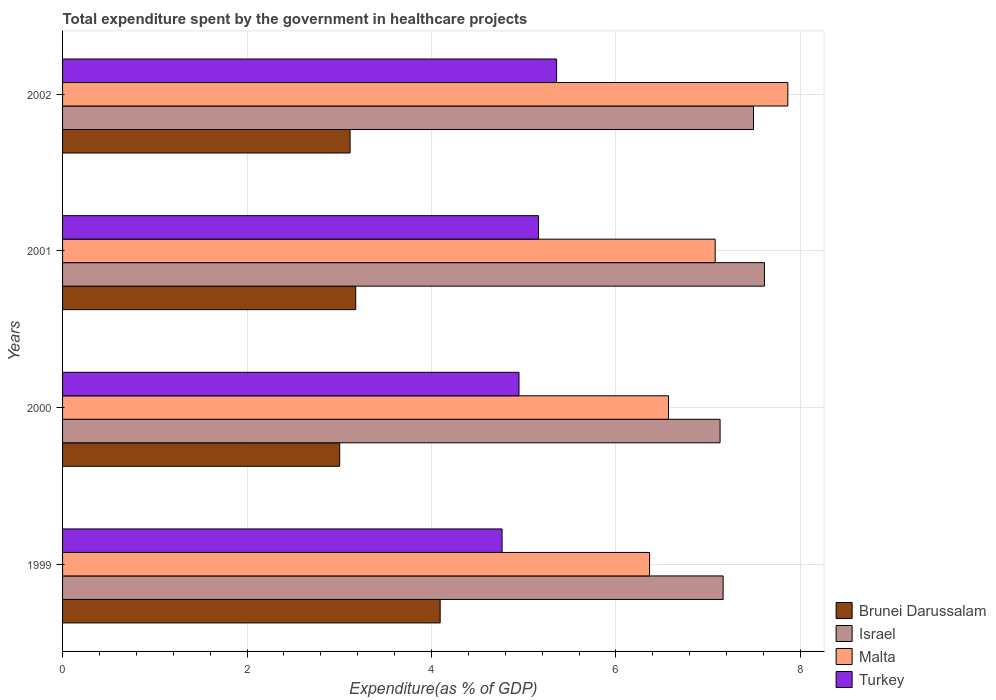How many bars are there on the 2nd tick from the top?
Your answer should be compact. 4. What is the label of the 2nd group of bars from the top?
Ensure brevity in your answer.  2001. In how many cases, is the number of bars for a given year not equal to the number of legend labels?
Provide a succinct answer. 0. What is the total expenditure spent by the government in healthcare projects in Malta in 2000?
Provide a short and direct response. 6.57. Across all years, what is the maximum total expenditure spent by the government in healthcare projects in Malta?
Your answer should be very brief. 7.86. Across all years, what is the minimum total expenditure spent by the government in healthcare projects in Israel?
Your answer should be very brief. 7.13. In which year was the total expenditure spent by the government in healthcare projects in Malta minimum?
Keep it short and to the point. 1999. What is the total total expenditure spent by the government in healthcare projects in Israel in the graph?
Your response must be concise. 29.39. What is the difference between the total expenditure spent by the government in healthcare projects in Brunei Darussalam in 2000 and that in 2001?
Your answer should be compact. -0.17. What is the difference between the total expenditure spent by the government in healthcare projects in Turkey in 1999 and the total expenditure spent by the government in healthcare projects in Israel in 2002?
Keep it short and to the point. -2.73. What is the average total expenditure spent by the government in healthcare projects in Israel per year?
Provide a succinct answer. 7.35. In the year 1999, what is the difference between the total expenditure spent by the government in healthcare projects in Turkey and total expenditure spent by the government in healthcare projects in Brunei Darussalam?
Give a very brief answer. 0.67. What is the ratio of the total expenditure spent by the government in healthcare projects in Brunei Darussalam in 2000 to that in 2002?
Ensure brevity in your answer.  0.96. Is the difference between the total expenditure spent by the government in healthcare projects in Turkey in 2001 and 2002 greater than the difference between the total expenditure spent by the government in healthcare projects in Brunei Darussalam in 2001 and 2002?
Give a very brief answer. No. What is the difference between the highest and the second highest total expenditure spent by the government in healthcare projects in Brunei Darussalam?
Make the answer very short. 0.92. What is the difference between the highest and the lowest total expenditure spent by the government in healthcare projects in Israel?
Your answer should be compact. 0.48. Is it the case that in every year, the sum of the total expenditure spent by the government in healthcare projects in Malta and total expenditure spent by the government in healthcare projects in Turkey is greater than the sum of total expenditure spent by the government in healthcare projects in Israel and total expenditure spent by the government in healthcare projects in Brunei Darussalam?
Your answer should be compact. Yes. What does the 1st bar from the bottom in 2001 represents?
Offer a terse response. Brunei Darussalam. Is it the case that in every year, the sum of the total expenditure spent by the government in healthcare projects in Israel and total expenditure spent by the government in healthcare projects in Malta is greater than the total expenditure spent by the government in healthcare projects in Brunei Darussalam?
Give a very brief answer. Yes. How many bars are there?
Ensure brevity in your answer.  16. Are all the bars in the graph horizontal?
Make the answer very short. Yes. How many years are there in the graph?
Your answer should be compact. 4. Are the values on the major ticks of X-axis written in scientific E-notation?
Offer a terse response. No. Does the graph contain any zero values?
Your answer should be very brief. No. Does the graph contain grids?
Provide a succinct answer. Yes. Where does the legend appear in the graph?
Provide a short and direct response. Bottom right. How are the legend labels stacked?
Your answer should be very brief. Vertical. What is the title of the graph?
Make the answer very short. Total expenditure spent by the government in healthcare projects. Does "Italy" appear as one of the legend labels in the graph?
Your answer should be compact. No. What is the label or title of the X-axis?
Offer a terse response. Expenditure(as % of GDP). What is the Expenditure(as % of GDP) in Brunei Darussalam in 1999?
Make the answer very short. 4.09. What is the Expenditure(as % of GDP) in Israel in 1999?
Offer a very short reply. 7.16. What is the Expenditure(as % of GDP) of Malta in 1999?
Provide a short and direct response. 6.36. What is the Expenditure(as % of GDP) in Turkey in 1999?
Keep it short and to the point. 4.77. What is the Expenditure(as % of GDP) in Brunei Darussalam in 2000?
Ensure brevity in your answer.  3. What is the Expenditure(as % of GDP) of Israel in 2000?
Give a very brief answer. 7.13. What is the Expenditure(as % of GDP) in Malta in 2000?
Your answer should be compact. 6.57. What is the Expenditure(as % of GDP) in Turkey in 2000?
Make the answer very short. 4.95. What is the Expenditure(as % of GDP) in Brunei Darussalam in 2001?
Keep it short and to the point. 3.18. What is the Expenditure(as % of GDP) in Israel in 2001?
Offer a very short reply. 7.61. What is the Expenditure(as % of GDP) of Malta in 2001?
Provide a succinct answer. 7.08. What is the Expenditure(as % of GDP) of Turkey in 2001?
Your response must be concise. 5.16. What is the Expenditure(as % of GDP) of Brunei Darussalam in 2002?
Your response must be concise. 3.12. What is the Expenditure(as % of GDP) of Israel in 2002?
Provide a short and direct response. 7.49. What is the Expenditure(as % of GDP) in Malta in 2002?
Offer a terse response. 7.86. What is the Expenditure(as % of GDP) of Turkey in 2002?
Provide a short and direct response. 5.36. Across all years, what is the maximum Expenditure(as % of GDP) of Brunei Darussalam?
Provide a succinct answer. 4.09. Across all years, what is the maximum Expenditure(as % of GDP) in Israel?
Provide a succinct answer. 7.61. Across all years, what is the maximum Expenditure(as % of GDP) in Malta?
Your response must be concise. 7.86. Across all years, what is the maximum Expenditure(as % of GDP) of Turkey?
Offer a very short reply. 5.36. Across all years, what is the minimum Expenditure(as % of GDP) in Brunei Darussalam?
Your answer should be very brief. 3. Across all years, what is the minimum Expenditure(as % of GDP) of Israel?
Give a very brief answer. 7.13. Across all years, what is the minimum Expenditure(as % of GDP) in Malta?
Make the answer very short. 6.36. Across all years, what is the minimum Expenditure(as % of GDP) of Turkey?
Keep it short and to the point. 4.77. What is the total Expenditure(as % of GDP) in Brunei Darussalam in the graph?
Provide a succinct answer. 13.39. What is the total Expenditure(as % of GDP) of Israel in the graph?
Give a very brief answer. 29.39. What is the total Expenditure(as % of GDP) in Malta in the graph?
Ensure brevity in your answer.  27.87. What is the total Expenditure(as % of GDP) of Turkey in the graph?
Keep it short and to the point. 20.23. What is the difference between the Expenditure(as % of GDP) of Brunei Darussalam in 1999 and that in 2000?
Offer a very short reply. 1.09. What is the difference between the Expenditure(as % of GDP) in Israel in 1999 and that in 2000?
Ensure brevity in your answer.  0.03. What is the difference between the Expenditure(as % of GDP) of Malta in 1999 and that in 2000?
Ensure brevity in your answer.  -0.21. What is the difference between the Expenditure(as % of GDP) of Turkey in 1999 and that in 2000?
Give a very brief answer. -0.18. What is the difference between the Expenditure(as % of GDP) in Brunei Darussalam in 1999 and that in 2001?
Your answer should be compact. 0.92. What is the difference between the Expenditure(as % of GDP) in Israel in 1999 and that in 2001?
Give a very brief answer. -0.45. What is the difference between the Expenditure(as % of GDP) of Malta in 1999 and that in 2001?
Offer a very short reply. -0.71. What is the difference between the Expenditure(as % of GDP) of Turkey in 1999 and that in 2001?
Offer a very short reply. -0.39. What is the difference between the Expenditure(as % of GDP) in Brunei Darussalam in 1999 and that in 2002?
Offer a very short reply. 0.98. What is the difference between the Expenditure(as % of GDP) in Israel in 1999 and that in 2002?
Provide a succinct answer. -0.33. What is the difference between the Expenditure(as % of GDP) of Malta in 1999 and that in 2002?
Your answer should be compact. -1.5. What is the difference between the Expenditure(as % of GDP) in Turkey in 1999 and that in 2002?
Offer a very short reply. -0.59. What is the difference between the Expenditure(as % of GDP) of Brunei Darussalam in 2000 and that in 2001?
Provide a short and direct response. -0.17. What is the difference between the Expenditure(as % of GDP) in Israel in 2000 and that in 2001?
Keep it short and to the point. -0.48. What is the difference between the Expenditure(as % of GDP) of Malta in 2000 and that in 2001?
Ensure brevity in your answer.  -0.51. What is the difference between the Expenditure(as % of GDP) of Turkey in 2000 and that in 2001?
Provide a short and direct response. -0.21. What is the difference between the Expenditure(as % of GDP) in Brunei Darussalam in 2000 and that in 2002?
Your answer should be compact. -0.11. What is the difference between the Expenditure(as % of GDP) of Israel in 2000 and that in 2002?
Offer a terse response. -0.36. What is the difference between the Expenditure(as % of GDP) in Malta in 2000 and that in 2002?
Provide a short and direct response. -1.29. What is the difference between the Expenditure(as % of GDP) in Turkey in 2000 and that in 2002?
Give a very brief answer. -0.41. What is the difference between the Expenditure(as % of GDP) of Brunei Darussalam in 2001 and that in 2002?
Provide a succinct answer. 0.06. What is the difference between the Expenditure(as % of GDP) of Israel in 2001 and that in 2002?
Ensure brevity in your answer.  0.12. What is the difference between the Expenditure(as % of GDP) of Malta in 2001 and that in 2002?
Offer a terse response. -0.79. What is the difference between the Expenditure(as % of GDP) of Turkey in 2001 and that in 2002?
Offer a very short reply. -0.2. What is the difference between the Expenditure(as % of GDP) of Brunei Darussalam in 1999 and the Expenditure(as % of GDP) of Israel in 2000?
Provide a succinct answer. -3.04. What is the difference between the Expenditure(as % of GDP) in Brunei Darussalam in 1999 and the Expenditure(as % of GDP) in Malta in 2000?
Provide a succinct answer. -2.48. What is the difference between the Expenditure(as % of GDP) of Brunei Darussalam in 1999 and the Expenditure(as % of GDP) of Turkey in 2000?
Your response must be concise. -0.85. What is the difference between the Expenditure(as % of GDP) of Israel in 1999 and the Expenditure(as % of GDP) of Malta in 2000?
Your answer should be compact. 0.59. What is the difference between the Expenditure(as % of GDP) of Israel in 1999 and the Expenditure(as % of GDP) of Turkey in 2000?
Your answer should be compact. 2.21. What is the difference between the Expenditure(as % of GDP) in Malta in 1999 and the Expenditure(as % of GDP) in Turkey in 2000?
Your answer should be compact. 1.42. What is the difference between the Expenditure(as % of GDP) in Brunei Darussalam in 1999 and the Expenditure(as % of GDP) in Israel in 2001?
Provide a succinct answer. -3.52. What is the difference between the Expenditure(as % of GDP) of Brunei Darussalam in 1999 and the Expenditure(as % of GDP) of Malta in 2001?
Provide a short and direct response. -2.98. What is the difference between the Expenditure(as % of GDP) in Brunei Darussalam in 1999 and the Expenditure(as % of GDP) in Turkey in 2001?
Offer a very short reply. -1.07. What is the difference between the Expenditure(as % of GDP) of Israel in 1999 and the Expenditure(as % of GDP) of Malta in 2001?
Provide a succinct answer. 0.09. What is the difference between the Expenditure(as % of GDP) of Israel in 1999 and the Expenditure(as % of GDP) of Turkey in 2001?
Offer a very short reply. 2. What is the difference between the Expenditure(as % of GDP) in Malta in 1999 and the Expenditure(as % of GDP) in Turkey in 2001?
Give a very brief answer. 1.2. What is the difference between the Expenditure(as % of GDP) in Brunei Darussalam in 1999 and the Expenditure(as % of GDP) in Israel in 2002?
Make the answer very short. -3.4. What is the difference between the Expenditure(as % of GDP) in Brunei Darussalam in 1999 and the Expenditure(as % of GDP) in Malta in 2002?
Provide a short and direct response. -3.77. What is the difference between the Expenditure(as % of GDP) in Brunei Darussalam in 1999 and the Expenditure(as % of GDP) in Turkey in 2002?
Keep it short and to the point. -1.26. What is the difference between the Expenditure(as % of GDP) of Israel in 1999 and the Expenditure(as % of GDP) of Malta in 2002?
Give a very brief answer. -0.7. What is the difference between the Expenditure(as % of GDP) of Israel in 1999 and the Expenditure(as % of GDP) of Turkey in 2002?
Ensure brevity in your answer.  1.81. What is the difference between the Expenditure(as % of GDP) in Malta in 1999 and the Expenditure(as % of GDP) in Turkey in 2002?
Your answer should be very brief. 1.01. What is the difference between the Expenditure(as % of GDP) in Brunei Darussalam in 2000 and the Expenditure(as % of GDP) in Israel in 2001?
Your answer should be compact. -4.61. What is the difference between the Expenditure(as % of GDP) of Brunei Darussalam in 2000 and the Expenditure(as % of GDP) of Malta in 2001?
Provide a short and direct response. -4.07. What is the difference between the Expenditure(as % of GDP) in Brunei Darussalam in 2000 and the Expenditure(as % of GDP) in Turkey in 2001?
Your response must be concise. -2.16. What is the difference between the Expenditure(as % of GDP) of Israel in 2000 and the Expenditure(as % of GDP) of Malta in 2001?
Give a very brief answer. 0.05. What is the difference between the Expenditure(as % of GDP) of Israel in 2000 and the Expenditure(as % of GDP) of Turkey in 2001?
Provide a succinct answer. 1.97. What is the difference between the Expenditure(as % of GDP) of Malta in 2000 and the Expenditure(as % of GDP) of Turkey in 2001?
Offer a very short reply. 1.41. What is the difference between the Expenditure(as % of GDP) in Brunei Darussalam in 2000 and the Expenditure(as % of GDP) in Israel in 2002?
Provide a succinct answer. -4.49. What is the difference between the Expenditure(as % of GDP) of Brunei Darussalam in 2000 and the Expenditure(as % of GDP) of Malta in 2002?
Offer a very short reply. -4.86. What is the difference between the Expenditure(as % of GDP) in Brunei Darussalam in 2000 and the Expenditure(as % of GDP) in Turkey in 2002?
Keep it short and to the point. -2.35. What is the difference between the Expenditure(as % of GDP) of Israel in 2000 and the Expenditure(as % of GDP) of Malta in 2002?
Make the answer very short. -0.73. What is the difference between the Expenditure(as % of GDP) of Israel in 2000 and the Expenditure(as % of GDP) of Turkey in 2002?
Ensure brevity in your answer.  1.77. What is the difference between the Expenditure(as % of GDP) in Malta in 2000 and the Expenditure(as % of GDP) in Turkey in 2002?
Your answer should be compact. 1.21. What is the difference between the Expenditure(as % of GDP) of Brunei Darussalam in 2001 and the Expenditure(as % of GDP) of Israel in 2002?
Make the answer very short. -4.31. What is the difference between the Expenditure(as % of GDP) of Brunei Darussalam in 2001 and the Expenditure(as % of GDP) of Malta in 2002?
Offer a very short reply. -4.69. What is the difference between the Expenditure(as % of GDP) of Brunei Darussalam in 2001 and the Expenditure(as % of GDP) of Turkey in 2002?
Ensure brevity in your answer.  -2.18. What is the difference between the Expenditure(as % of GDP) in Israel in 2001 and the Expenditure(as % of GDP) in Malta in 2002?
Provide a succinct answer. -0.25. What is the difference between the Expenditure(as % of GDP) in Israel in 2001 and the Expenditure(as % of GDP) in Turkey in 2002?
Offer a very short reply. 2.25. What is the difference between the Expenditure(as % of GDP) of Malta in 2001 and the Expenditure(as % of GDP) of Turkey in 2002?
Offer a very short reply. 1.72. What is the average Expenditure(as % of GDP) of Brunei Darussalam per year?
Keep it short and to the point. 3.35. What is the average Expenditure(as % of GDP) of Israel per year?
Your answer should be compact. 7.35. What is the average Expenditure(as % of GDP) of Malta per year?
Keep it short and to the point. 6.97. What is the average Expenditure(as % of GDP) of Turkey per year?
Provide a short and direct response. 5.06. In the year 1999, what is the difference between the Expenditure(as % of GDP) in Brunei Darussalam and Expenditure(as % of GDP) in Israel?
Offer a very short reply. -3.07. In the year 1999, what is the difference between the Expenditure(as % of GDP) of Brunei Darussalam and Expenditure(as % of GDP) of Malta?
Offer a very short reply. -2.27. In the year 1999, what is the difference between the Expenditure(as % of GDP) in Brunei Darussalam and Expenditure(as % of GDP) in Turkey?
Your response must be concise. -0.67. In the year 1999, what is the difference between the Expenditure(as % of GDP) of Israel and Expenditure(as % of GDP) of Malta?
Offer a very short reply. 0.8. In the year 1999, what is the difference between the Expenditure(as % of GDP) of Israel and Expenditure(as % of GDP) of Turkey?
Your answer should be very brief. 2.4. In the year 1999, what is the difference between the Expenditure(as % of GDP) in Malta and Expenditure(as % of GDP) in Turkey?
Offer a terse response. 1.6. In the year 2000, what is the difference between the Expenditure(as % of GDP) of Brunei Darussalam and Expenditure(as % of GDP) of Israel?
Your answer should be compact. -4.12. In the year 2000, what is the difference between the Expenditure(as % of GDP) of Brunei Darussalam and Expenditure(as % of GDP) of Malta?
Your answer should be compact. -3.57. In the year 2000, what is the difference between the Expenditure(as % of GDP) of Brunei Darussalam and Expenditure(as % of GDP) of Turkey?
Your answer should be very brief. -1.94. In the year 2000, what is the difference between the Expenditure(as % of GDP) of Israel and Expenditure(as % of GDP) of Malta?
Your answer should be compact. 0.56. In the year 2000, what is the difference between the Expenditure(as % of GDP) of Israel and Expenditure(as % of GDP) of Turkey?
Keep it short and to the point. 2.18. In the year 2000, what is the difference between the Expenditure(as % of GDP) of Malta and Expenditure(as % of GDP) of Turkey?
Offer a terse response. 1.62. In the year 2001, what is the difference between the Expenditure(as % of GDP) in Brunei Darussalam and Expenditure(as % of GDP) in Israel?
Provide a short and direct response. -4.43. In the year 2001, what is the difference between the Expenditure(as % of GDP) in Brunei Darussalam and Expenditure(as % of GDP) in Malta?
Offer a terse response. -3.9. In the year 2001, what is the difference between the Expenditure(as % of GDP) of Brunei Darussalam and Expenditure(as % of GDP) of Turkey?
Keep it short and to the point. -1.98. In the year 2001, what is the difference between the Expenditure(as % of GDP) of Israel and Expenditure(as % of GDP) of Malta?
Make the answer very short. 0.53. In the year 2001, what is the difference between the Expenditure(as % of GDP) of Israel and Expenditure(as % of GDP) of Turkey?
Offer a terse response. 2.45. In the year 2001, what is the difference between the Expenditure(as % of GDP) of Malta and Expenditure(as % of GDP) of Turkey?
Keep it short and to the point. 1.92. In the year 2002, what is the difference between the Expenditure(as % of GDP) of Brunei Darussalam and Expenditure(as % of GDP) of Israel?
Offer a terse response. -4.37. In the year 2002, what is the difference between the Expenditure(as % of GDP) of Brunei Darussalam and Expenditure(as % of GDP) of Malta?
Keep it short and to the point. -4.75. In the year 2002, what is the difference between the Expenditure(as % of GDP) in Brunei Darussalam and Expenditure(as % of GDP) in Turkey?
Your answer should be compact. -2.24. In the year 2002, what is the difference between the Expenditure(as % of GDP) of Israel and Expenditure(as % of GDP) of Malta?
Ensure brevity in your answer.  -0.37. In the year 2002, what is the difference between the Expenditure(as % of GDP) of Israel and Expenditure(as % of GDP) of Turkey?
Provide a short and direct response. 2.13. In the year 2002, what is the difference between the Expenditure(as % of GDP) in Malta and Expenditure(as % of GDP) in Turkey?
Your answer should be compact. 2.51. What is the ratio of the Expenditure(as % of GDP) in Brunei Darussalam in 1999 to that in 2000?
Your response must be concise. 1.36. What is the ratio of the Expenditure(as % of GDP) in Israel in 1999 to that in 2000?
Your answer should be compact. 1. What is the ratio of the Expenditure(as % of GDP) of Malta in 1999 to that in 2000?
Your response must be concise. 0.97. What is the ratio of the Expenditure(as % of GDP) of Turkey in 1999 to that in 2000?
Offer a terse response. 0.96. What is the ratio of the Expenditure(as % of GDP) in Brunei Darussalam in 1999 to that in 2001?
Your response must be concise. 1.29. What is the ratio of the Expenditure(as % of GDP) of Israel in 1999 to that in 2001?
Provide a succinct answer. 0.94. What is the ratio of the Expenditure(as % of GDP) in Malta in 1999 to that in 2001?
Ensure brevity in your answer.  0.9. What is the ratio of the Expenditure(as % of GDP) of Turkey in 1999 to that in 2001?
Your response must be concise. 0.92. What is the ratio of the Expenditure(as % of GDP) in Brunei Darussalam in 1999 to that in 2002?
Your answer should be very brief. 1.31. What is the ratio of the Expenditure(as % of GDP) in Israel in 1999 to that in 2002?
Your answer should be compact. 0.96. What is the ratio of the Expenditure(as % of GDP) of Malta in 1999 to that in 2002?
Your response must be concise. 0.81. What is the ratio of the Expenditure(as % of GDP) in Turkey in 1999 to that in 2002?
Provide a short and direct response. 0.89. What is the ratio of the Expenditure(as % of GDP) in Brunei Darussalam in 2000 to that in 2001?
Offer a very short reply. 0.95. What is the ratio of the Expenditure(as % of GDP) of Israel in 2000 to that in 2001?
Offer a terse response. 0.94. What is the ratio of the Expenditure(as % of GDP) in Malta in 2000 to that in 2001?
Your response must be concise. 0.93. What is the ratio of the Expenditure(as % of GDP) in Turkey in 2000 to that in 2001?
Provide a short and direct response. 0.96. What is the ratio of the Expenditure(as % of GDP) of Brunei Darussalam in 2000 to that in 2002?
Keep it short and to the point. 0.96. What is the ratio of the Expenditure(as % of GDP) of Israel in 2000 to that in 2002?
Provide a short and direct response. 0.95. What is the ratio of the Expenditure(as % of GDP) of Malta in 2000 to that in 2002?
Make the answer very short. 0.84. What is the ratio of the Expenditure(as % of GDP) in Turkey in 2000 to that in 2002?
Provide a short and direct response. 0.92. What is the ratio of the Expenditure(as % of GDP) in Brunei Darussalam in 2001 to that in 2002?
Keep it short and to the point. 1.02. What is the ratio of the Expenditure(as % of GDP) in Israel in 2001 to that in 2002?
Offer a terse response. 1.02. What is the ratio of the Expenditure(as % of GDP) of Malta in 2001 to that in 2002?
Keep it short and to the point. 0.9. What is the ratio of the Expenditure(as % of GDP) of Turkey in 2001 to that in 2002?
Provide a succinct answer. 0.96. What is the difference between the highest and the second highest Expenditure(as % of GDP) in Brunei Darussalam?
Offer a terse response. 0.92. What is the difference between the highest and the second highest Expenditure(as % of GDP) in Israel?
Keep it short and to the point. 0.12. What is the difference between the highest and the second highest Expenditure(as % of GDP) of Malta?
Ensure brevity in your answer.  0.79. What is the difference between the highest and the second highest Expenditure(as % of GDP) in Turkey?
Your answer should be compact. 0.2. What is the difference between the highest and the lowest Expenditure(as % of GDP) of Brunei Darussalam?
Your response must be concise. 1.09. What is the difference between the highest and the lowest Expenditure(as % of GDP) in Israel?
Your response must be concise. 0.48. What is the difference between the highest and the lowest Expenditure(as % of GDP) of Malta?
Make the answer very short. 1.5. What is the difference between the highest and the lowest Expenditure(as % of GDP) of Turkey?
Offer a terse response. 0.59. 